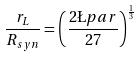Convert formula to latex. <formula><loc_0><loc_0><loc_500><loc_500>\frac { r _ { L } } { R _ { s y n } } = \left ( \frac { 2 \L p a r } { 2 7 } \right ) ^ { \frac { 1 } { 3 } }</formula> 